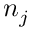Convert formula to latex. <formula><loc_0><loc_0><loc_500><loc_500>n _ { j }</formula> 